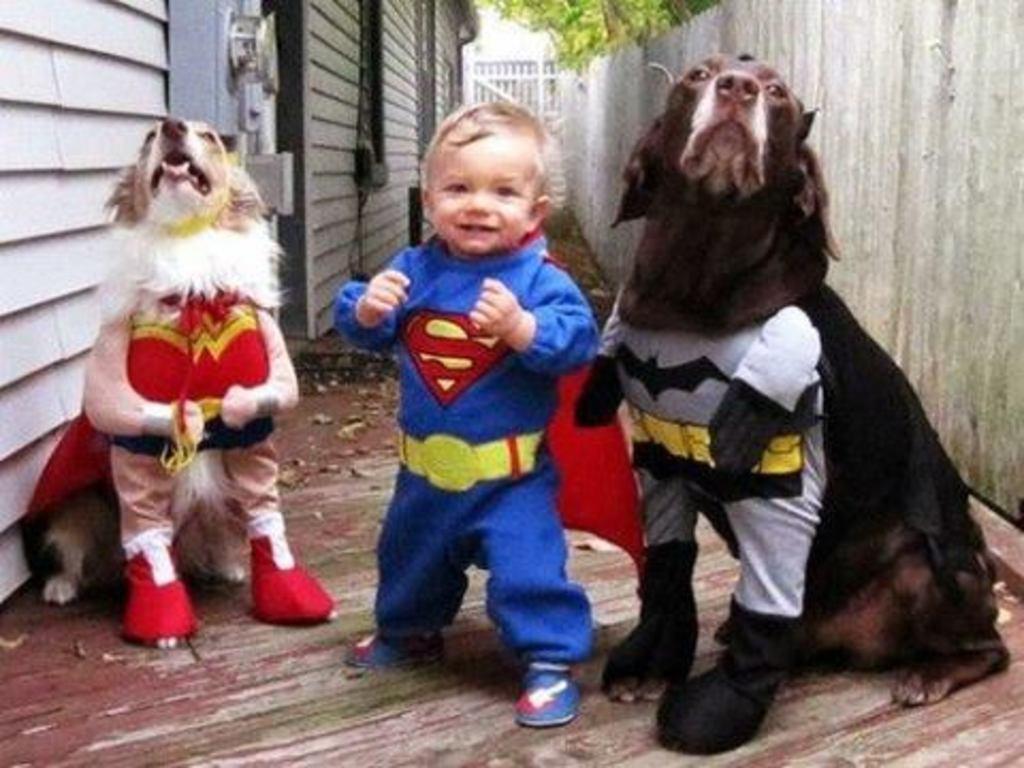Please provide a concise description of this image. In the center of the image we can see one kid and two dogs and we can see they are in different costumes. And we can see the kid is smiling. In the background there is a wall, tree and a few other objects. 